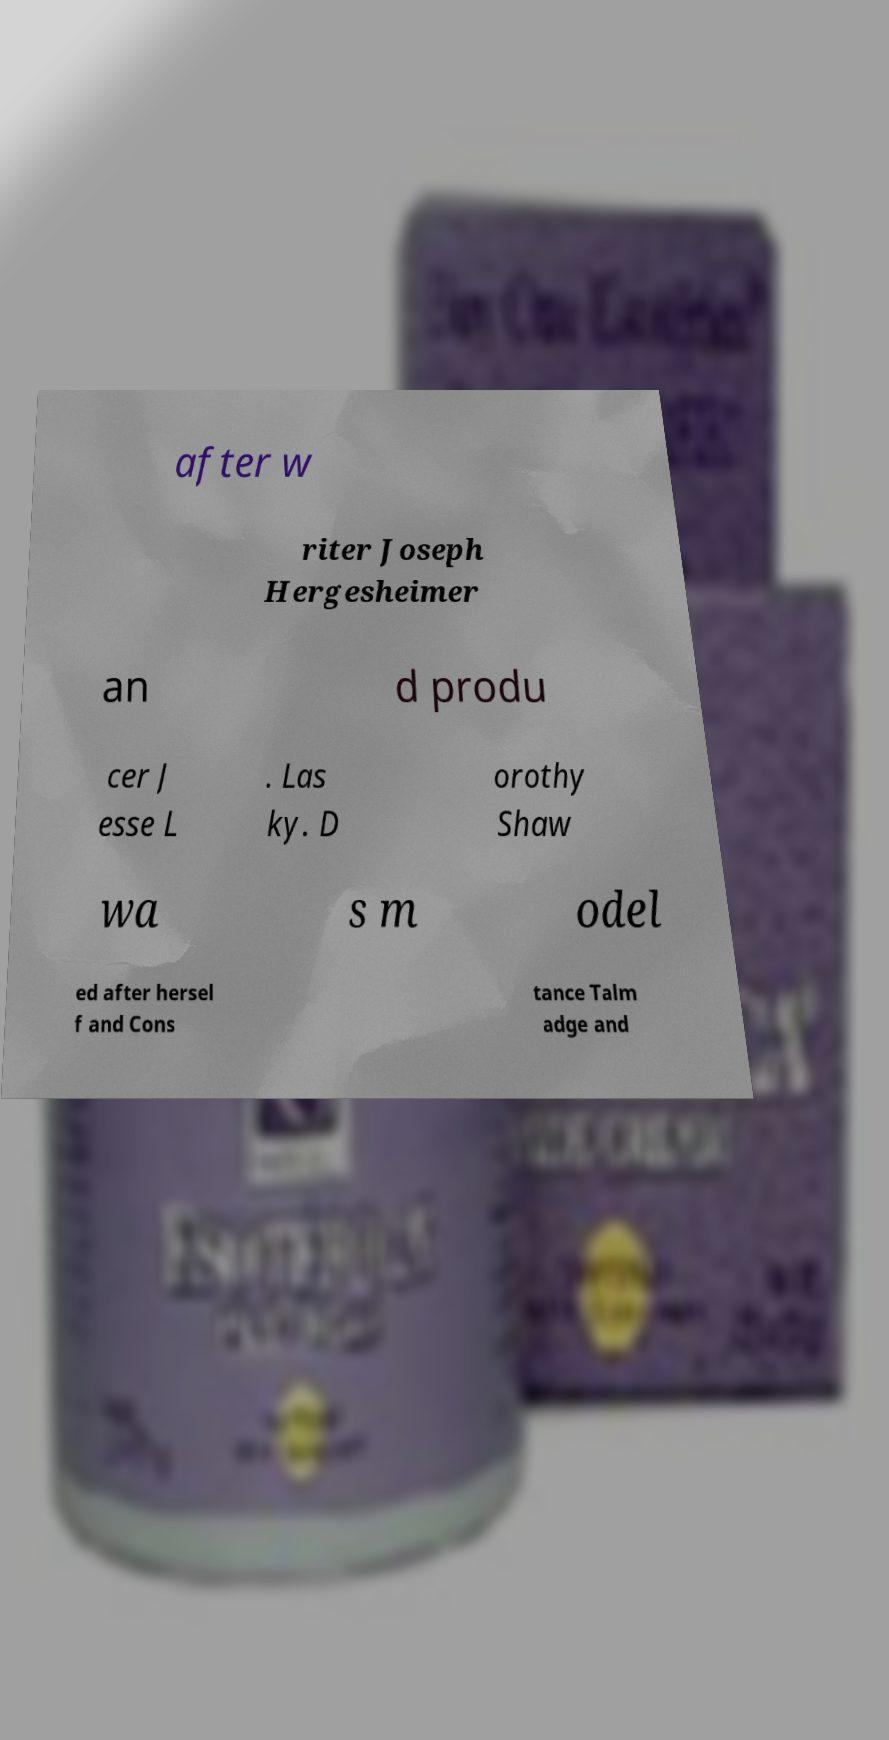For documentation purposes, I need the text within this image transcribed. Could you provide that? after w riter Joseph Hergesheimer an d produ cer J esse L . Las ky. D orothy Shaw wa s m odel ed after hersel f and Cons tance Talm adge and 